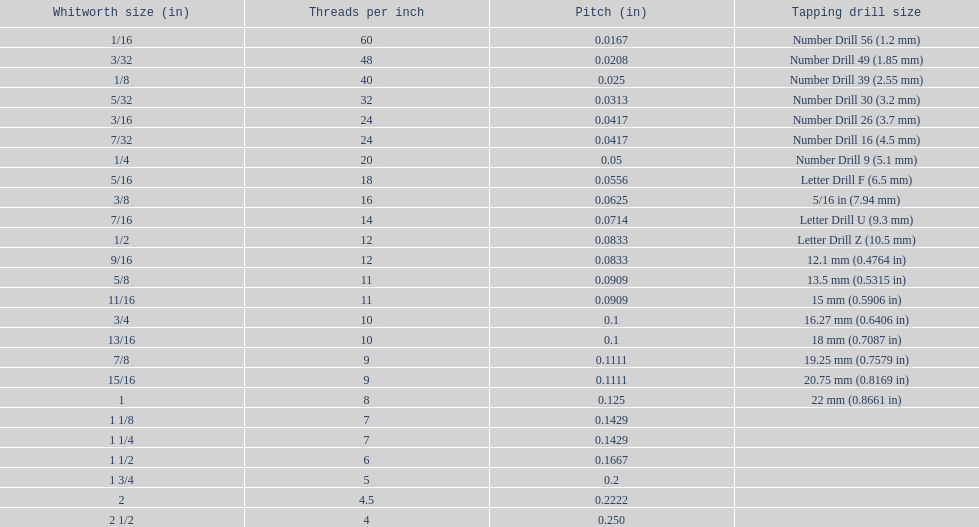How many more threads per inch does the 1/16th whitworth size have over the 1/8th whitworth size? 20. 